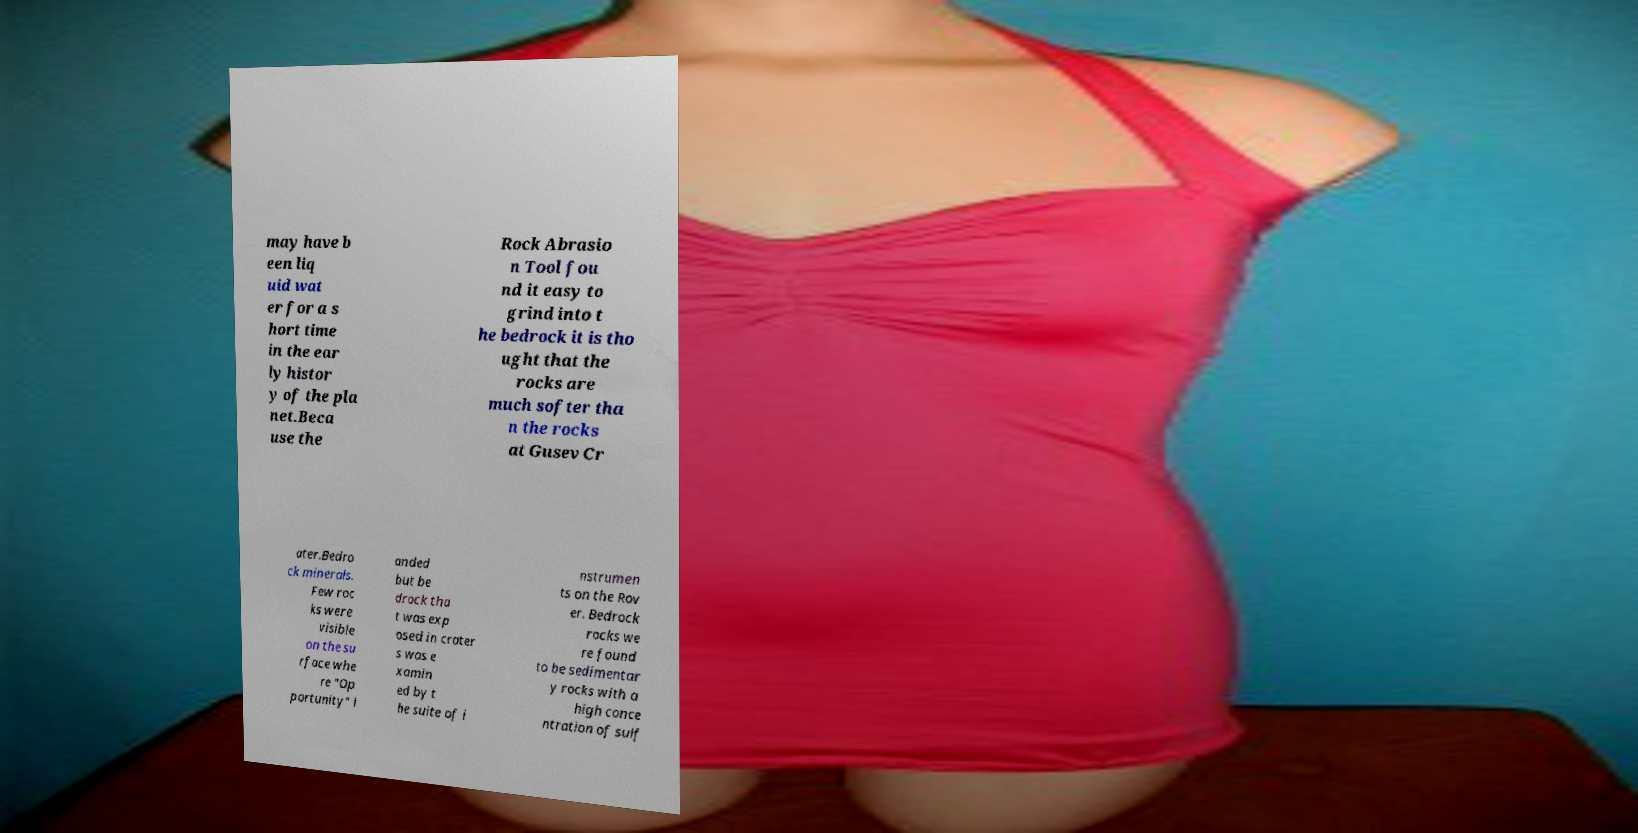What messages or text are displayed in this image? I need them in a readable, typed format. may have b een liq uid wat er for a s hort time in the ear ly histor y of the pla net.Beca use the Rock Abrasio n Tool fou nd it easy to grind into t he bedrock it is tho ught that the rocks are much softer tha n the rocks at Gusev Cr ater.Bedro ck minerals. Few roc ks were visible on the su rface whe re "Op portunity" l anded but be drock tha t was exp osed in crater s was e xamin ed by t he suite of i nstrumen ts on the Rov er. Bedrock rocks we re found to be sedimentar y rocks with a high conce ntration of sulf 